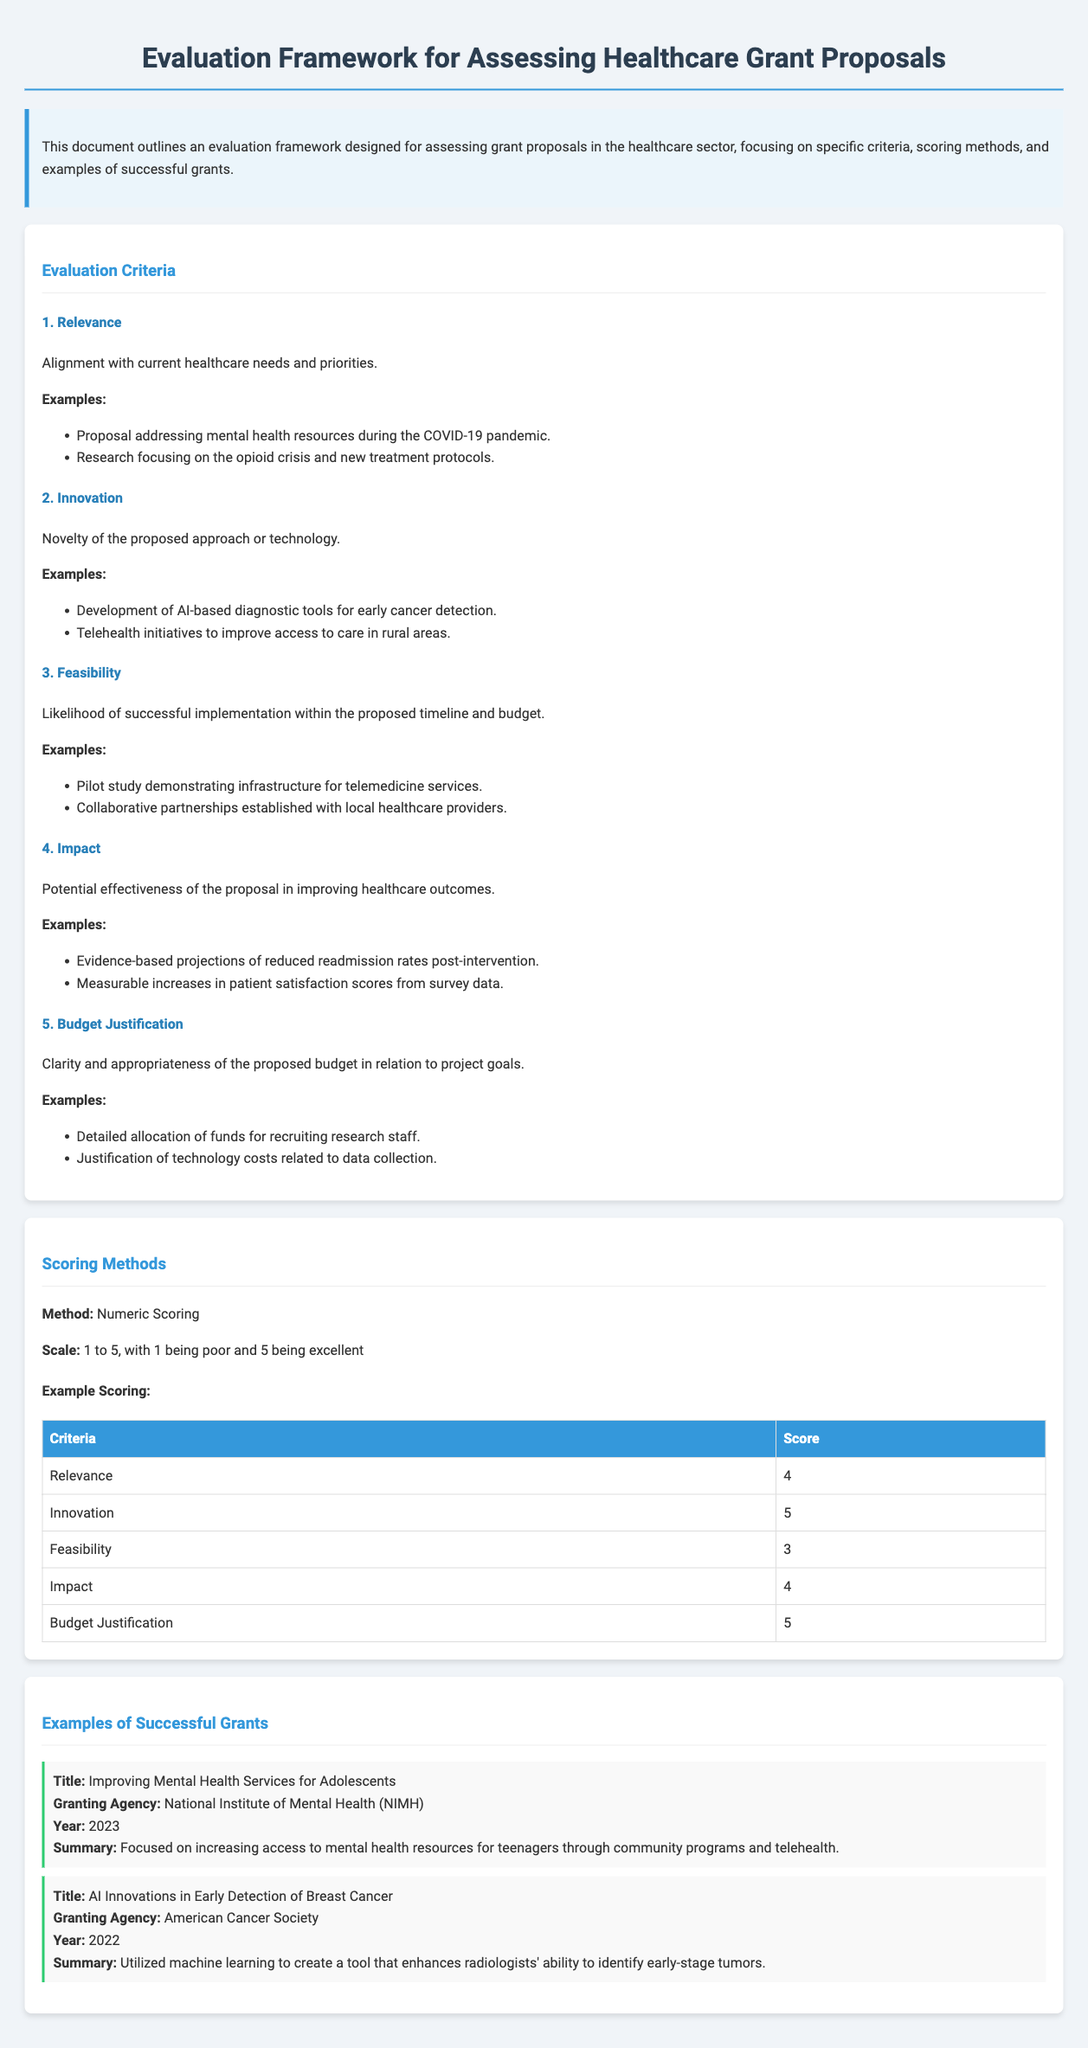What is the title of the document? The title of the document is stated in the header section clearly.
Answer: Evaluation Framework for Assessing Healthcare Grant Proposals What are the five evaluation criteria listed? The criteria are listed under the Evaluation Criteria section.
Answer: Relevance, Innovation, Feasibility, Impact, Budget Justification What scoring scale is used for evaluating the proposals? The scoring method section provides a specific scale for scores.
Answer: 1 to 5 Which granting agency funded the grant titled "AI Innovations in Early Detection of Breast Cancer"? This information is found within the Examples of Successful Grants section.
Answer: American Cancer Society What score was given for the criterion "Feasibility"? The scoring table provides individual scores for each criterion.
Answer: 3 What year was the grant titled "Improving Mental Health Services for Adolescents" awarded? The year is mentioned in the details of the successful grant examples.
Answer: 2023 What is the primary focus of the proposal addressing the opioid crisis? The focus is mentioned in the examples under the relevance criterion.
Answer: New treatment protocols How many successful grant examples are provided? The number of examples can be counted from the listing in the document.
Answer: 2 What is the impact criterion concerned with? The description of the impact criterion clarifies its focus.
Answer: Improving healthcare outcomes 